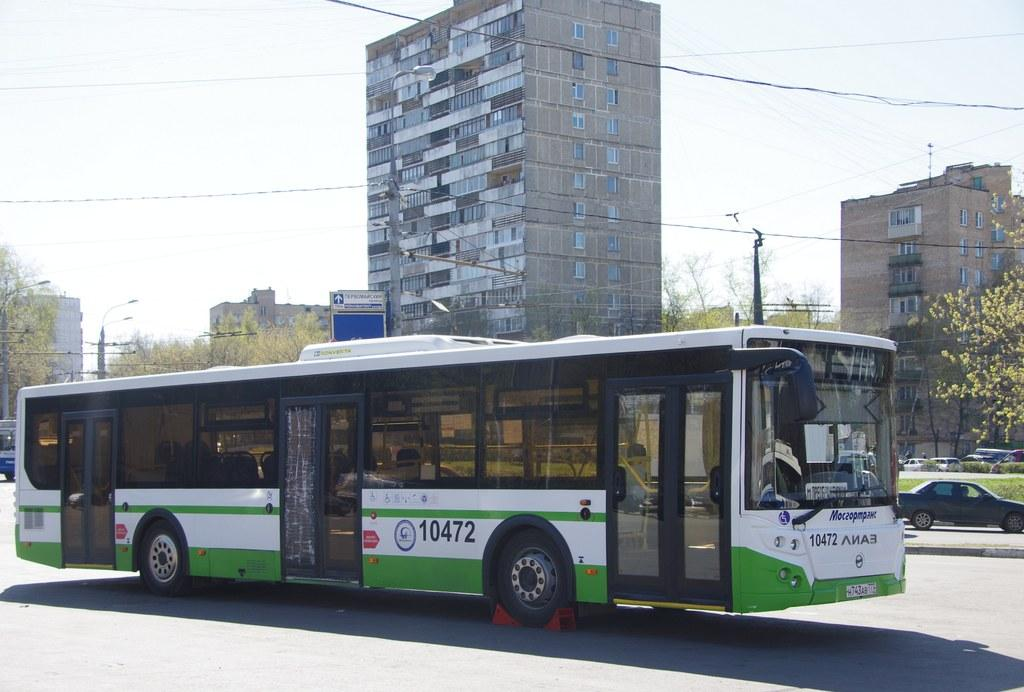<image>
Render a clear and concise summary of the photo. A white and green bus with the numbers 10472 on the side. 